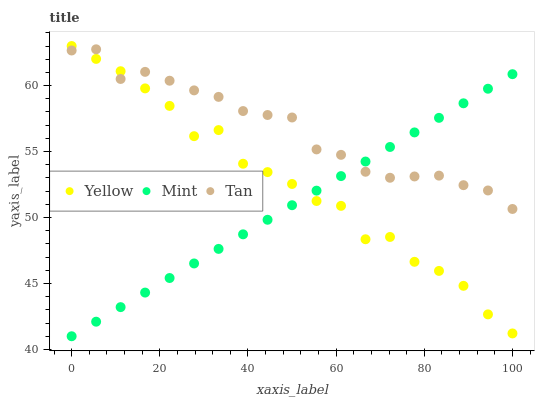Does Mint have the minimum area under the curve?
Answer yes or no. Yes. Does Tan have the maximum area under the curve?
Answer yes or no. Yes. Does Yellow have the minimum area under the curve?
Answer yes or no. No. Does Yellow have the maximum area under the curve?
Answer yes or no. No. Is Mint the smoothest?
Answer yes or no. Yes. Is Yellow the roughest?
Answer yes or no. Yes. Is Yellow the smoothest?
Answer yes or no. No. Is Mint the roughest?
Answer yes or no. No. Does Mint have the lowest value?
Answer yes or no. Yes. Does Yellow have the lowest value?
Answer yes or no. No. Does Yellow have the highest value?
Answer yes or no. Yes. Does Mint have the highest value?
Answer yes or no. No. Does Tan intersect Yellow?
Answer yes or no. Yes. Is Tan less than Yellow?
Answer yes or no. No. Is Tan greater than Yellow?
Answer yes or no. No. 